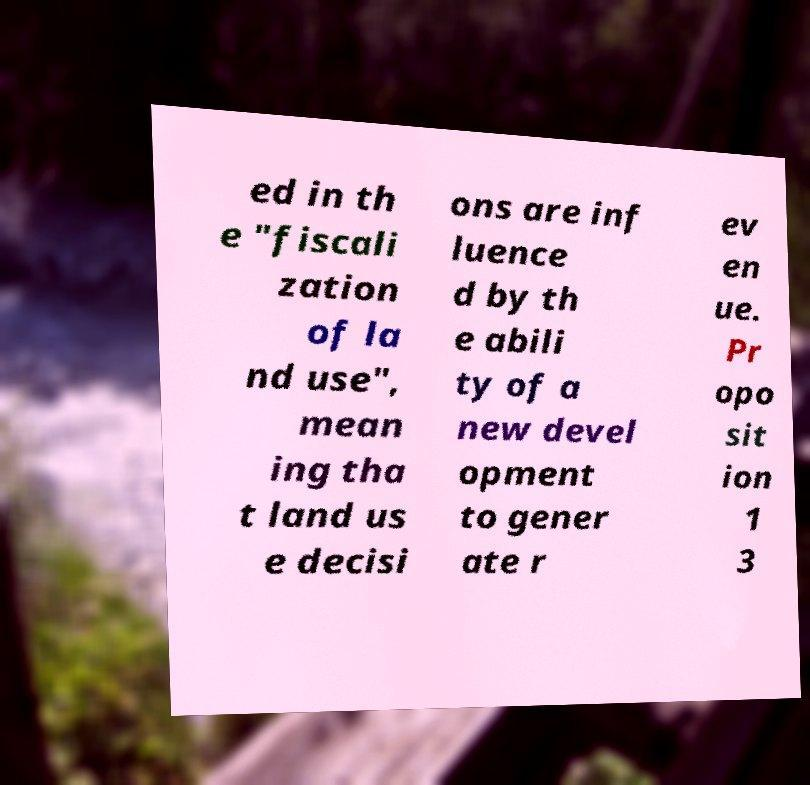Could you extract and type out the text from this image? ed in th e "fiscali zation of la nd use", mean ing tha t land us e decisi ons are inf luence d by th e abili ty of a new devel opment to gener ate r ev en ue. Pr opo sit ion 1 3 